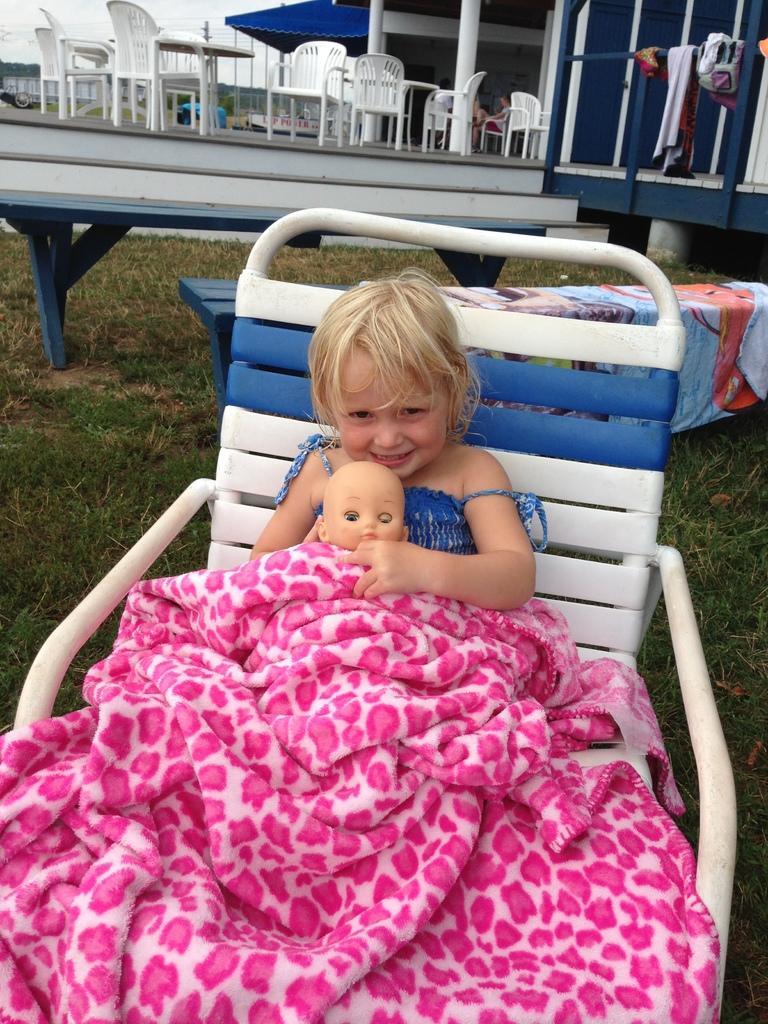Could you give a brief overview of what you see in this image? In the image there is a baby girl in blue dress sitting on chair holding a doll with a blanket over her on grassland, behind her there is a home with many chairs and tables in front of it. 